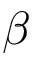<formula> <loc_0><loc_0><loc_500><loc_500>\beta</formula> 